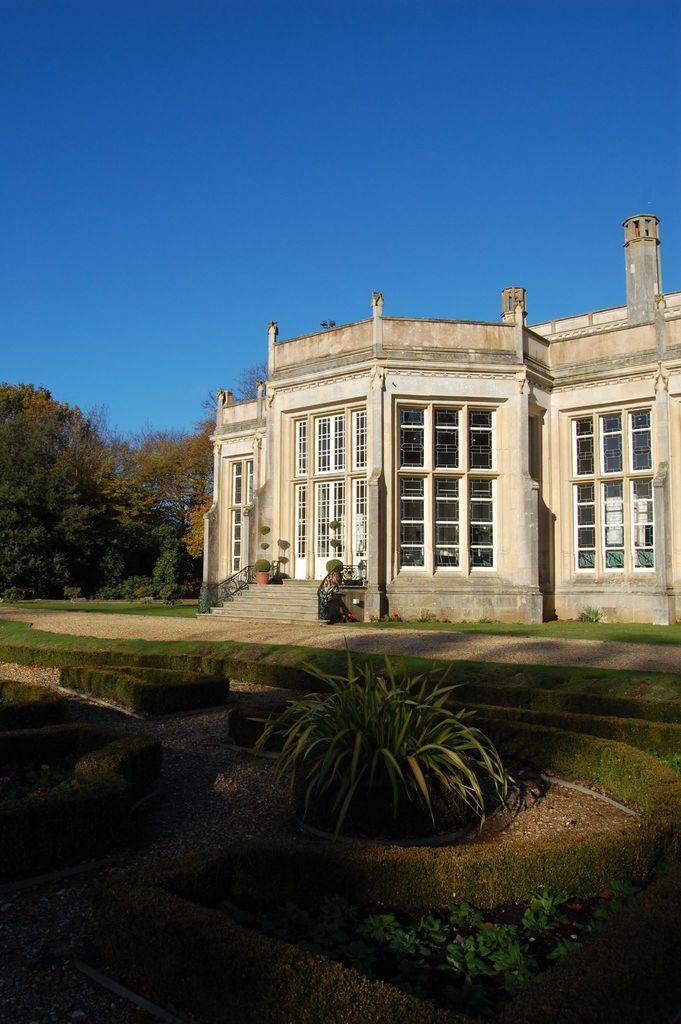Describe this image in one or two sentences. In this image we can see there is a big building beside that there are so many trees and also there is grass and plants. 